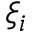<formula> <loc_0><loc_0><loc_500><loc_500>\xi _ { i }</formula> 